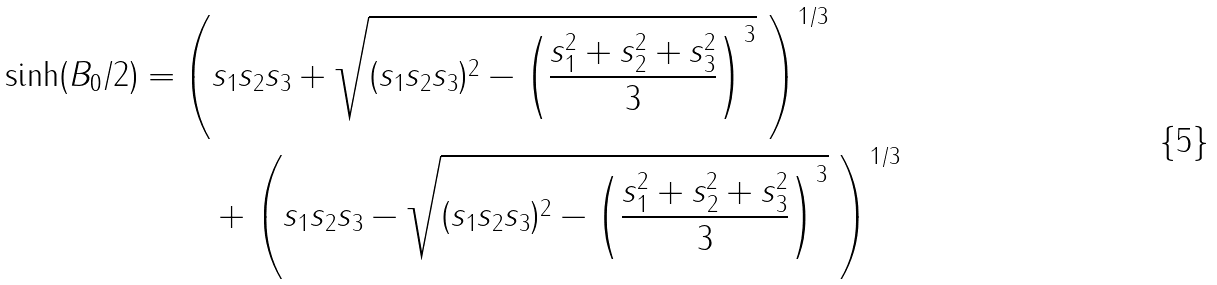<formula> <loc_0><loc_0><loc_500><loc_500>\sinh ( B _ { 0 } / 2 ) = & \left ( s _ { 1 } s _ { 2 } s _ { 3 } + \sqrt { ( s _ { 1 } s _ { 2 } s _ { 3 } ) ^ { 2 } - \left ( \frac { s _ { 1 } ^ { 2 } + s _ { 2 } ^ { 2 } + s _ { 3 } ^ { 2 } } { 3 } \right ) ^ { 3 } } \ \right ) ^ { 1 / 3 } \\ & \quad + \left ( s _ { 1 } s _ { 2 } s _ { 3 } - \sqrt { ( s _ { 1 } s _ { 2 } s _ { 3 } ) ^ { 2 } - \left ( \frac { s _ { 1 } ^ { 2 } + s _ { 2 } ^ { 2 } + s _ { 3 } ^ { 2 } } { 3 } \right ) ^ { 3 } } \ \right ) ^ { 1 / 3 }</formula> 